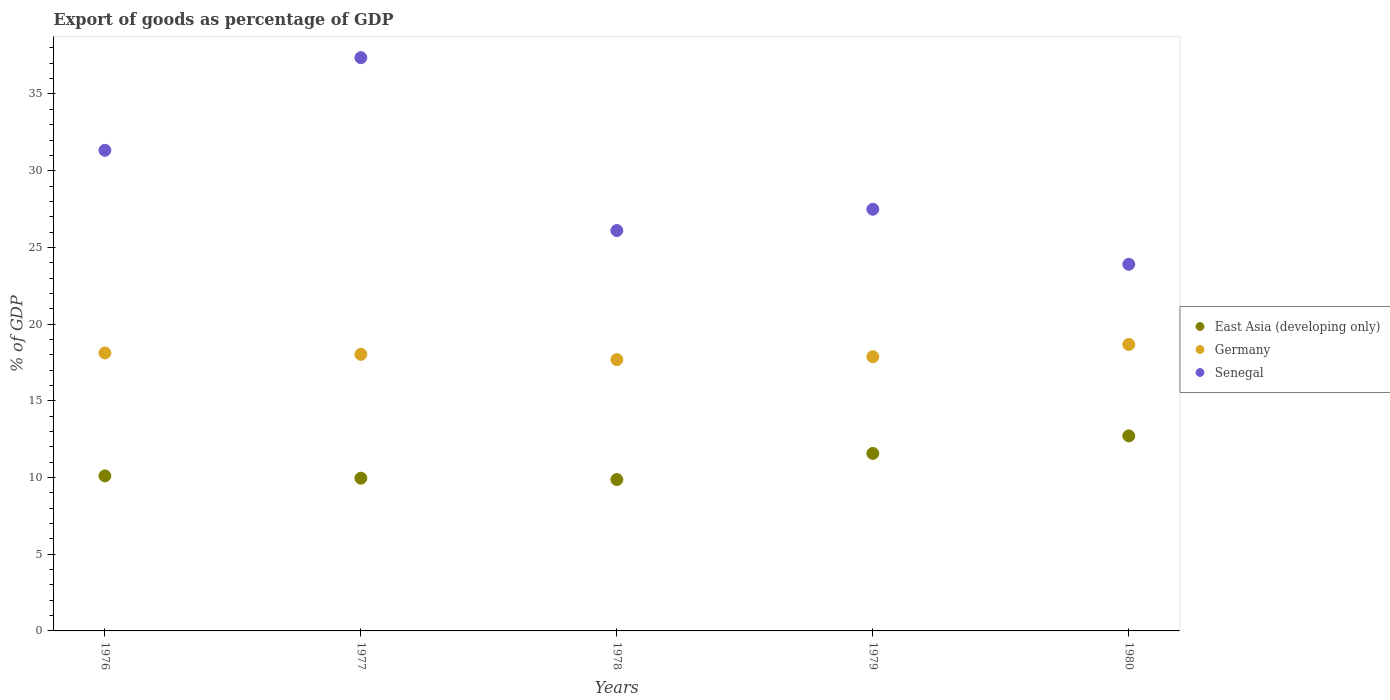How many different coloured dotlines are there?
Your answer should be compact. 3. What is the export of goods as percentage of GDP in Senegal in 1980?
Give a very brief answer. 23.9. Across all years, what is the maximum export of goods as percentage of GDP in Senegal?
Offer a terse response. 37.37. Across all years, what is the minimum export of goods as percentage of GDP in Germany?
Provide a short and direct response. 17.69. In which year was the export of goods as percentage of GDP in Senegal maximum?
Offer a terse response. 1977. In which year was the export of goods as percentage of GDP in East Asia (developing only) minimum?
Provide a succinct answer. 1978. What is the total export of goods as percentage of GDP in Germany in the graph?
Your answer should be very brief. 90.38. What is the difference between the export of goods as percentage of GDP in Senegal in 1978 and that in 1980?
Provide a succinct answer. 2.2. What is the difference between the export of goods as percentage of GDP in Germany in 1979 and the export of goods as percentage of GDP in Senegal in 1980?
Make the answer very short. -6.02. What is the average export of goods as percentage of GDP in Senegal per year?
Provide a succinct answer. 29.24. In the year 1976, what is the difference between the export of goods as percentage of GDP in East Asia (developing only) and export of goods as percentage of GDP in Germany?
Provide a succinct answer. -8.01. What is the ratio of the export of goods as percentage of GDP in East Asia (developing only) in 1978 to that in 1980?
Provide a succinct answer. 0.78. Is the export of goods as percentage of GDP in East Asia (developing only) in 1977 less than that in 1979?
Provide a succinct answer. Yes. What is the difference between the highest and the second highest export of goods as percentage of GDP in East Asia (developing only)?
Provide a short and direct response. 1.14. What is the difference between the highest and the lowest export of goods as percentage of GDP in East Asia (developing only)?
Offer a terse response. 2.85. In how many years, is the export of goods as percentage of GDP in East Asia (developing only) greater than the average export of goods as percentage of GDP in East Asia (developing only) taken over all years?
Provide a short and direct response. 2. Is it the case that in every year, the sum of the export of goods as percentage of GDP in Senegal and export of goods as percentage of GDP in Germany  is greater than the export of goods as percentage of GDP in East Asia (developing only)?
Ensure brevity in your answer.  Yes. Is the export of goods as percentage of GDP in Germany strictly greater than the export of goods as percentage of GDP in Senegal over the years?
Provide a succinct answer. No. Is the export of goods as percentage of GDP in Senegal strictly less than the export of goods as percentage of GDP in Germany over the years?
Give a very brief answer. No. How many dotlines are there?
Your response must be concise. 3. What is the difference between two consecutive major ticks on the Y-axis?
Your answer should be very brief. 5. Are the values on the major ticks of Y-axis written in scientific E-notation?
Provide a short and direct response. No. How many legend labels are there?
Ensure brevity in your answer.  3. How are the legend labels stacked?
Ensure brevity in your answer.  Vertical. What is the title of the graph?
Keep it short and to the point. Export of goods as percentage of GDP. What is the label or title of the Y-axis?
Offer a terse response. % of GDP. What is the % of GDP in East Asia (developing only) in 1976?
Give a very brief answer. 10.11. What is the % of GDP of Germany in 1976?
Your response must be concise. 18.12. What is the % of GDP in Senegal in 1976?
Your answer should be very brief. 31.33. What is the % of GDP of East Asia (developing only) in 1977?
Keep it short and to the point. 9.95. What is the % of GDP of Germany in 1977?
Make the answer very short. 18.03. What is the % of GDP of Senegal in 1977?
Provide a short and direct response. 37.37. What is the % of GDP of East Asia (developing only) in 1978?
Provide a succinct answer. 9.87. What is the % of GDP in Germany in 1978?
Ensure brevity in your answer.  17.69. What is the % of GDP in Senegal in 1978?
Ensure brevity in your answer.  26.1. What is the % of GDP in East Asia (developing only) in 1979?
Offer a very short reply. 11.57. What is the % of GDP of Germany in 1979?
Make the answer very short. 17.87. What is the % of GDP in Senegal in 1979?
Your answer should be very brief. 27.49. What is the % of GDP of East Asia (developing only) in 1980?
Provide a short and direct response. 12.71. What is the % of GDP in Germany in 1980?
Offer a terse response. 18.67. What is the % of GDP of Senegal in 1980?
Provide a short and direct response. 23.9. Across all years, what is the maximum % of GDP in East Asia (developing only)?
Give a very brief answer. 12.71. Across all years, what is the maximum % of GDP in Germany?
Provide a succinct answer. 18.67. Across all years, what is the maximum % of GDP of Senegal?
Ensure brevity in your answer.  37.37. Across all years, what is the minimum % of GDP in East Asia (developing only)?
Provide a short and direct response. 9.87. Across all years, what is the minimum % of GDP of Germany?
Ensure brevity in your answer.  17.69. Across all years, what is the minimum % of GDP in Senegal?
Your answer should be compact. 23.9. What is the total % of GDP of East Asia (developing only) in the graph?
Your response must be concise. 54.21. What is the total % of GDP in Germany in the graph?
Provide a short and direct response. 90.38. What is the total % of GDP of Senegal in the graph?
Your response must be concise. 146.18. What is the difference between the % of GDP of East Asia (developing only) in 1976 and that in 1977?
Give a very brief answer. 0.15. What is the difference between the % of GDP of Germany in 1976 and that in 1977?
Make the answer very short. 0.09. What is the difference between the % of GDP in Senegal in 1976 and that in 1977?
Keep it short and to the point. -6.04. What is the difference between the % of GDP of East Asia (developing only) in 1976 and that in 1978?
Offer a very short reply. 0.24. What is the difference between the % of GDP of Germany in 1976 and that in 1978?
Ensure brevity in your answer.  0.44. What is the difference between the % of GDP in Senegal in 1976 and that in 1978?
Your answer should be very brief. 5.23. What is the difference between the % of GDP of East Asia (developing only) in 1976 and that in 1979?
Offer a very short reply. -1.46. What is the difference between the % of GDP in Germany in 1976 and that in 1979?
Your answer should be very brief. 0.25. What is the difference between the % of GDP of Senegal in 1976 and that in 1979?
Your answer should be very brief. 3.84. What is the difference between the % of GDP of East Asia (developing only) in 1976 and that in 1980?
Keep it short and to the point. -2.61. What is the difference between the % of GDP in Germany in 1976 and that in 1980?
Give a very brief answer. -0.55. What is the difference between the % of GDP of Senegal in 1976 and that in 1980?
Your answer should be compact. 7.43. What is the difference between the % of GDP in East Asia (developing only) in 1977 and that in 1978?
Ensure brevity in your answer.  0.09. What is the difference between the % of GDP of Germany in 1977 and that in 1978?
Offer a terse response. 0.34. What is the difference between the % of GDP of Senegal in 1977 and that in 1978?
Your response must be concise. 11.27. What is the difference between the % of GDP of East Asia (developing only) in 1977 and that in 1979?
Make the answer very short. -1.62. What is the difference between the % of GDP in Germany in 1977 and that in 1979?
Keep it short and to the point. 0.16. What is the difference between the % of GDP in Senegal in 1977 and that in 1979?
Provide a succinct answer. 9.88. What is the difference between the % of GDP of East Asia (developing only) in 1977 and that in 1980?
Offer a terse response. -2.76. What is the difference between the % of GDP in Germany in 1977 and that in 1980?
Ensure brevity in your answer.  -0.64. What is the difference between the % of GDP in Senegal in 1977 and that in 1980?
Your answer should be very brief. 13.47. What is the difference between the % of GDP in East Asia (developing only) in 1978 and that in 1979?
Give a very brief answer. -1.7. What is the difference between the % of GDP of Germany in 1978 and that in 1979?
Your response must be concise. -0.19. What is the difference between the % of GDP in Senegal in 1978 and that in 1979?
Give a very brief answer. -1.39. What is the difference between the % of GDP in East Asia (developing only) in 1978 and that in 1980?
Provide a short and direct response. -2.85. What is the difference between the % of GDP of Germany in 1978 and that in 1980?
Keep it short and to the point. -0.99. What is the difference between the % of GDP in Senegal in 1978 and that in 1980?
Make the answer very short. 2.2. What is the difference between the % of GDP of East Asia (developing only) in 1979 and that in 1980?
Make the answer very short. -1.14. What is the difference between the % of GDP in Germany in 1979 and that in 1980?
Provide a short and direct response. -0.8. What is the difference between the % of GDP in Senegal in 1979 and that in 1980?
Give a very brief answer. 3.59. What is the difference between the % of GDP in East Asia (developing only) in 1976 and the % of GDP in Germany in 1977?
Provide a short and direct response. -7.92. What is the difference between the % of GDP in East Asia (developing only) in 1976 and the % of GDP in Senegal in 1977?
Make the answer very short. -27.26. What is the difference between the % of GDP of Germany in 1976 and the % of GDP of Senegal in 1977?
Ensure brevity in your answer.  -19.25. What is the difference between the % of GDP in East Asia (developing only) in 1976 and the % of GDP in Germany in 1978?
Provide a short and direct response. -7.58. What is the difference between the % of GDP of East Asia (developing only) in 1976 and the % of GDP of Senegal in 1978?
Ensure brevity in your answer.  -15.99. What is the difference between the % of GDP in Germany in 1976 and the % of GDP in Senegal in 1978?
Offer a terse response. -7.98. What is the difference between the % of GDP of East Asia (developing only) in 1976 and the % of GDP of Germany in 1979?
Make the answer very short. -7.77. What is the difference between the % of GDP in East Asia (developing only) in 1976 and the % of GDP in Senegal in 1979?
Your answer should be very brief. -17.38. What is the difference between the % of GDP of Germany in 1976 and the % of GDP of Senegal in 1979?
Your answer should be compact. -9.37. What is the difference between the % of GDP of East Asia (developing only) in 1976 and the % of GDP of Germany in 1980?
Your answer should be compact. -8.57. What is the difference between the % of GDP in East Asia (developing only) in 1976 and the % of GDP in Senegal in 1980?
Provide a succinct answer. -13.79. What is the difference between the % of GDP in Germany in 1976 and the % of GDP in Senegal in 1980?
Give a very brief answer. -5.78. What is the difference between the % of GDP of East Asia (developing only) in 1977 and the % of GDP of Germany in 1978?
Offer a very short reply. -7.73. What is the difference between the % of GDP of East Asia (developing only) in 1977 and the % of GDP of Senegal in 1978?
Offer a very short reply. -16.14. What is the difference between the % of GDP of Germany in 1977 and the % of GDP of Senegal in 1978?
Provide a short and direct response. -8.07. What is the difference between the % of GDP in East Asia (developing only) in 1977 and the % of GDP in Germany in 1979?
Your answer should be very brief. -7.92. What is the difference between the % of GDP of East Asia (developing only) in 1977 and the % of GDP of Senegal in 1979?
Provide a succinct answer. -17.53. What is the difference between the % of GDP in Germany in 1977 and the % of GDP in Senegal in 1979?
Ensure brevity in your answer.  -9.46. What is the difference between the % of GDP of East Asia (developing only) in 1977 and the % of GDP of Germany in 1980?
Offer a terse response. -8.72. What is the difference between the % of GDP in East Asia (developing only) in 1977 and the % of GDP in Senegal in 1980?
Give a very brief answer. -13.94. What is the difference between the % of GDP of Germany in 1977 and the % of GDP of Senegal in 1980?
Your response must be concise. -5.87. What is the difference between the % of GDP in East Asia (developing only) in 1978 and the % of GDP in Germany in 1979?
Provide a short and direct response. -8.01. What is the difference between the % of GDP of East Asia (developing only) in 1978 and the % of GDP of Senegal in 1979?
Your answer should be compact. -17.62. What is the difference between the % of GDP in Germany in 1978 and the % of GDP in Senegal in 1979?
Make the answer very short. -9.8. What is the difference between the % of GDP of East Asia (developing only) in 1978 and the % of GDP of Germany in 1980?
Provide a succinct answer. -8.8. What is the difference between the % of GDP in East Asia (developing only) in 1978 and the % of GDP in Senegal in 1980?
Ensure brevity in your answer.  -14.03. What is the difference between the % of GDP of Germany in 1978 and the % of GDP of Senegal in 1980?
Provide a short and direct response. -6.21. What is the difference between the % of GDP of East Asia (developing only) in 1979 and the % of GDP of Germany in 1980?
Provide a succinct answer. -7.1. What is the difference between the % of GDP of East Asia (developing only) in 1979 and the % of GDP of Senegal in 1980?
Your answer should be very brief. -12.33. What is the difference between the % of GDP of Germany in 1979 and the % of GDP of Senegal in 1980?
Make the answer very short. -6.03. What is the average % of GDP in East Asia (developing only) per year?
Make the answer very short. 10.84. What is the average % of GDP of Germany per year?
Your answer should be very brief. 18.08. What is the average % of GDP in Senegal per year?
Ensure brevity in your answer.  29.24. In the year 1976, what is the difference between the % of GDP of East Asia (developing only) and % of GDP of Germany?
Give a very brief answer. -8.01. In the year 1976, what is the difference between the % of GDP of East Asia (developing only) and % of GDP of Senegal?
Offer a very short reply. -21.22. In the year 1976, what is the difference between the % of GDP of Germany and % of GDP of Senegal?
Ensure brevity in your answer.  -13.21. In the year 1977, what is the difference between the % of GDP of East Asia (developing only) and % of GDP of Germany?
Provide a succinct answer. -8.08. In the year 1977, what is the difference between the % of GDP of East Asia (developing only) and % of GDP of Senegal?
Make the answer very short. -27.41. In the year 1977, what is the difference between the % of GDP in Germany and % of GDP in Senegal?
Ensure brevity in your answer.  -19.34. In the year 1978, what is the difference between the % of GDP in East Asia (developing only) and % of GDP in Germany?
Your answer should be compact. -7.82. In the year 1978, what is the difference between the % of GDP of East Asia (developing only) and % of GDP of Senegal?
Your response must be concise. -16.23. In the year 1978, what is the difference between the % of GDP in Germany and % of GDP in Senegal?
Make the answer very short. -8.41. In the year 1979, what is the difference between the % of GDP in East Asia (developing only) and % of GDP in Germany?
Make the answer very short. -6.3. In the year 1979, what is the difference between the % of GDP in East Asia (developing only) and % of GDP in Senegal?
Provide a succinct answer. -15.92. In the year 1979, what is the difference between the % of GDP in Germany and % of GDP in Senegal?
Provide a succinct answer. -9.61. In the year 1980, what is the difference between the % of GDP of East Asia (developing only) and % of GDP of Germany?
Keep it short and to the point. -5.96. In the year 1980, what is the difference between the % of GDP in East Asia (developing only) and % of GDP in Senegal?
Keep it short and to the point. -11.18. In the year 1980, what is the difference between the % of GDP in Germany and % of GDP in Senegal?
Your answer should be compact. -5.23. What is the ratio of the % of GDP in East Asia (developing only) in 1976 to that in 1977?
Ensure brevity in your answer.  1.02. What is the ratio of the % of GDP of Senegal in 1976 to that in 1977?
Offer a terse response. 0.84. What is the ratio of the % of GDP in East Asia (developing only) in 1976 to that in 1978?
Make the answer very short. 1.02. What is the ratio of the % of GDP in Germany in 1976 to that in 1978?
Make the answer very short. 1.02. What is the ratio of the % of GDP of Senegal in 1976 to that in 1978?
Make the answer very short. 1.2. What is the ratio of the % of GDP of East Asia (developing only) in 1976 to that in 1979?
Your answer should be compact. 0.87. What is the ratio of the % of GDP in Germany in 1976 to that in 1979?
Keep it short and to the point. 1.01. What is the ratio of the % of GDP of Senegal in 1976 to that in 1979?
Offer a very short reply. 1.14. What is the ratio of the % of GDP of East Asia (developing only) in 1976 to that in 1980?
Your answer should be compact. 0.79. What is the ratio of the % of GDP in Germany in 1976 to that in 1980?
Your answer should be compact. 0.97. What is the ratio of the % of GDP of Senegal in 1976 to that in 1980?
Your answer should be compact. 1.31. What is the ratio of the % of GDP in East Asia (developing only) in 1977 to that in 1978?
Your answer should be compact. 1.01. What is the ratio of the % of GDP of Germany in 1977 to that in 1978?
Provide a succinct answer. 1.02. What is the ratio of the % of GDP in Senegal in 1977 to that in 1978?
Keep it short and to the point. 1.43. What is the ratio of the % of GDP of East Asia (developing only) in 1977 to that in 1979?
Provide a succinct answer. 0.86. What is the ratio of the % of GDP in Germany in 1977 to that in 1979?
Provide a short and direct response. 1.01. What is the ratio of the % of GDP in Senegal in 1977 to that in 1979?
Offer a terse response. 1.36. What is the ratio of the % of GDP of East Asia (developing only) in 1977 to that in 1980?
Offer a terse response. 0.78. What is the ratio of the % of GDP of Germany in 1977 to that in 1980?
Your response must be concise. 0.97. What is the ratio of the % of GDP in Senegal in 1977 to that in 1980?
Offer a very short reply. 1.56. What is the ratio of the % of GDP of East Asia (developing only) in 1978 to that in 1979?
Offer a terse response. 0.85. What is the ratio of the % of GDP of Germany in 1978 to that in 1979?
Provide a succinct answer. 0.99. What is the ratio of the % of GDP in Senegal in 1978 to that in 1979?
Offer a terse response. 0.95. What is the ratio of the % of GDP of East Asia (developing only) in 1978 to that in 1980?
Your answer should be very brief. 0.78. What is the ratio of the % of GDP of Germany in 1978 to that in 1980?
Your answer should be very brief. 0.95. What is the ratio of the % of GDP in Senegal in 1978 to that in 1980?
Your answer should be very brief. 1.09. What is the ratio of the % of GDP in East Asia (developing only) in 1979 to that in 1980?
Provide a short and direct response. 0.91. What is the ratio of the % of GDP in Germany in 1979 to that in 1980?
Provide a succinct answer. 0.96. What is the ratio of the % of GDP in Senegal in 1979 to that in 1980?
Your answer should be compact. 1.15. What is the difference between the highest and the second highest % of GDP in East Asia (developing only)?
Keep it short and to the point. 1.14. What is the difference between the highest and the second highest % of GDP in Germany?
Provide a short and direct response. 0.55. What is the difference between the highest and the second highest % of GDP of Senegal?
Give a very brief answer. 6.04. What is the difference between the highest and the lowest % of GDP in East Asia (developing only)?
Offer a very short reply. 2.85. What is the difference between the highest and the lowest % of GDP of Germany?
Make the answer very short. 0.99. What is the difference between the highest and the lowest % of GDP of Senegal?
Provide a short and direct response. 13.47. 